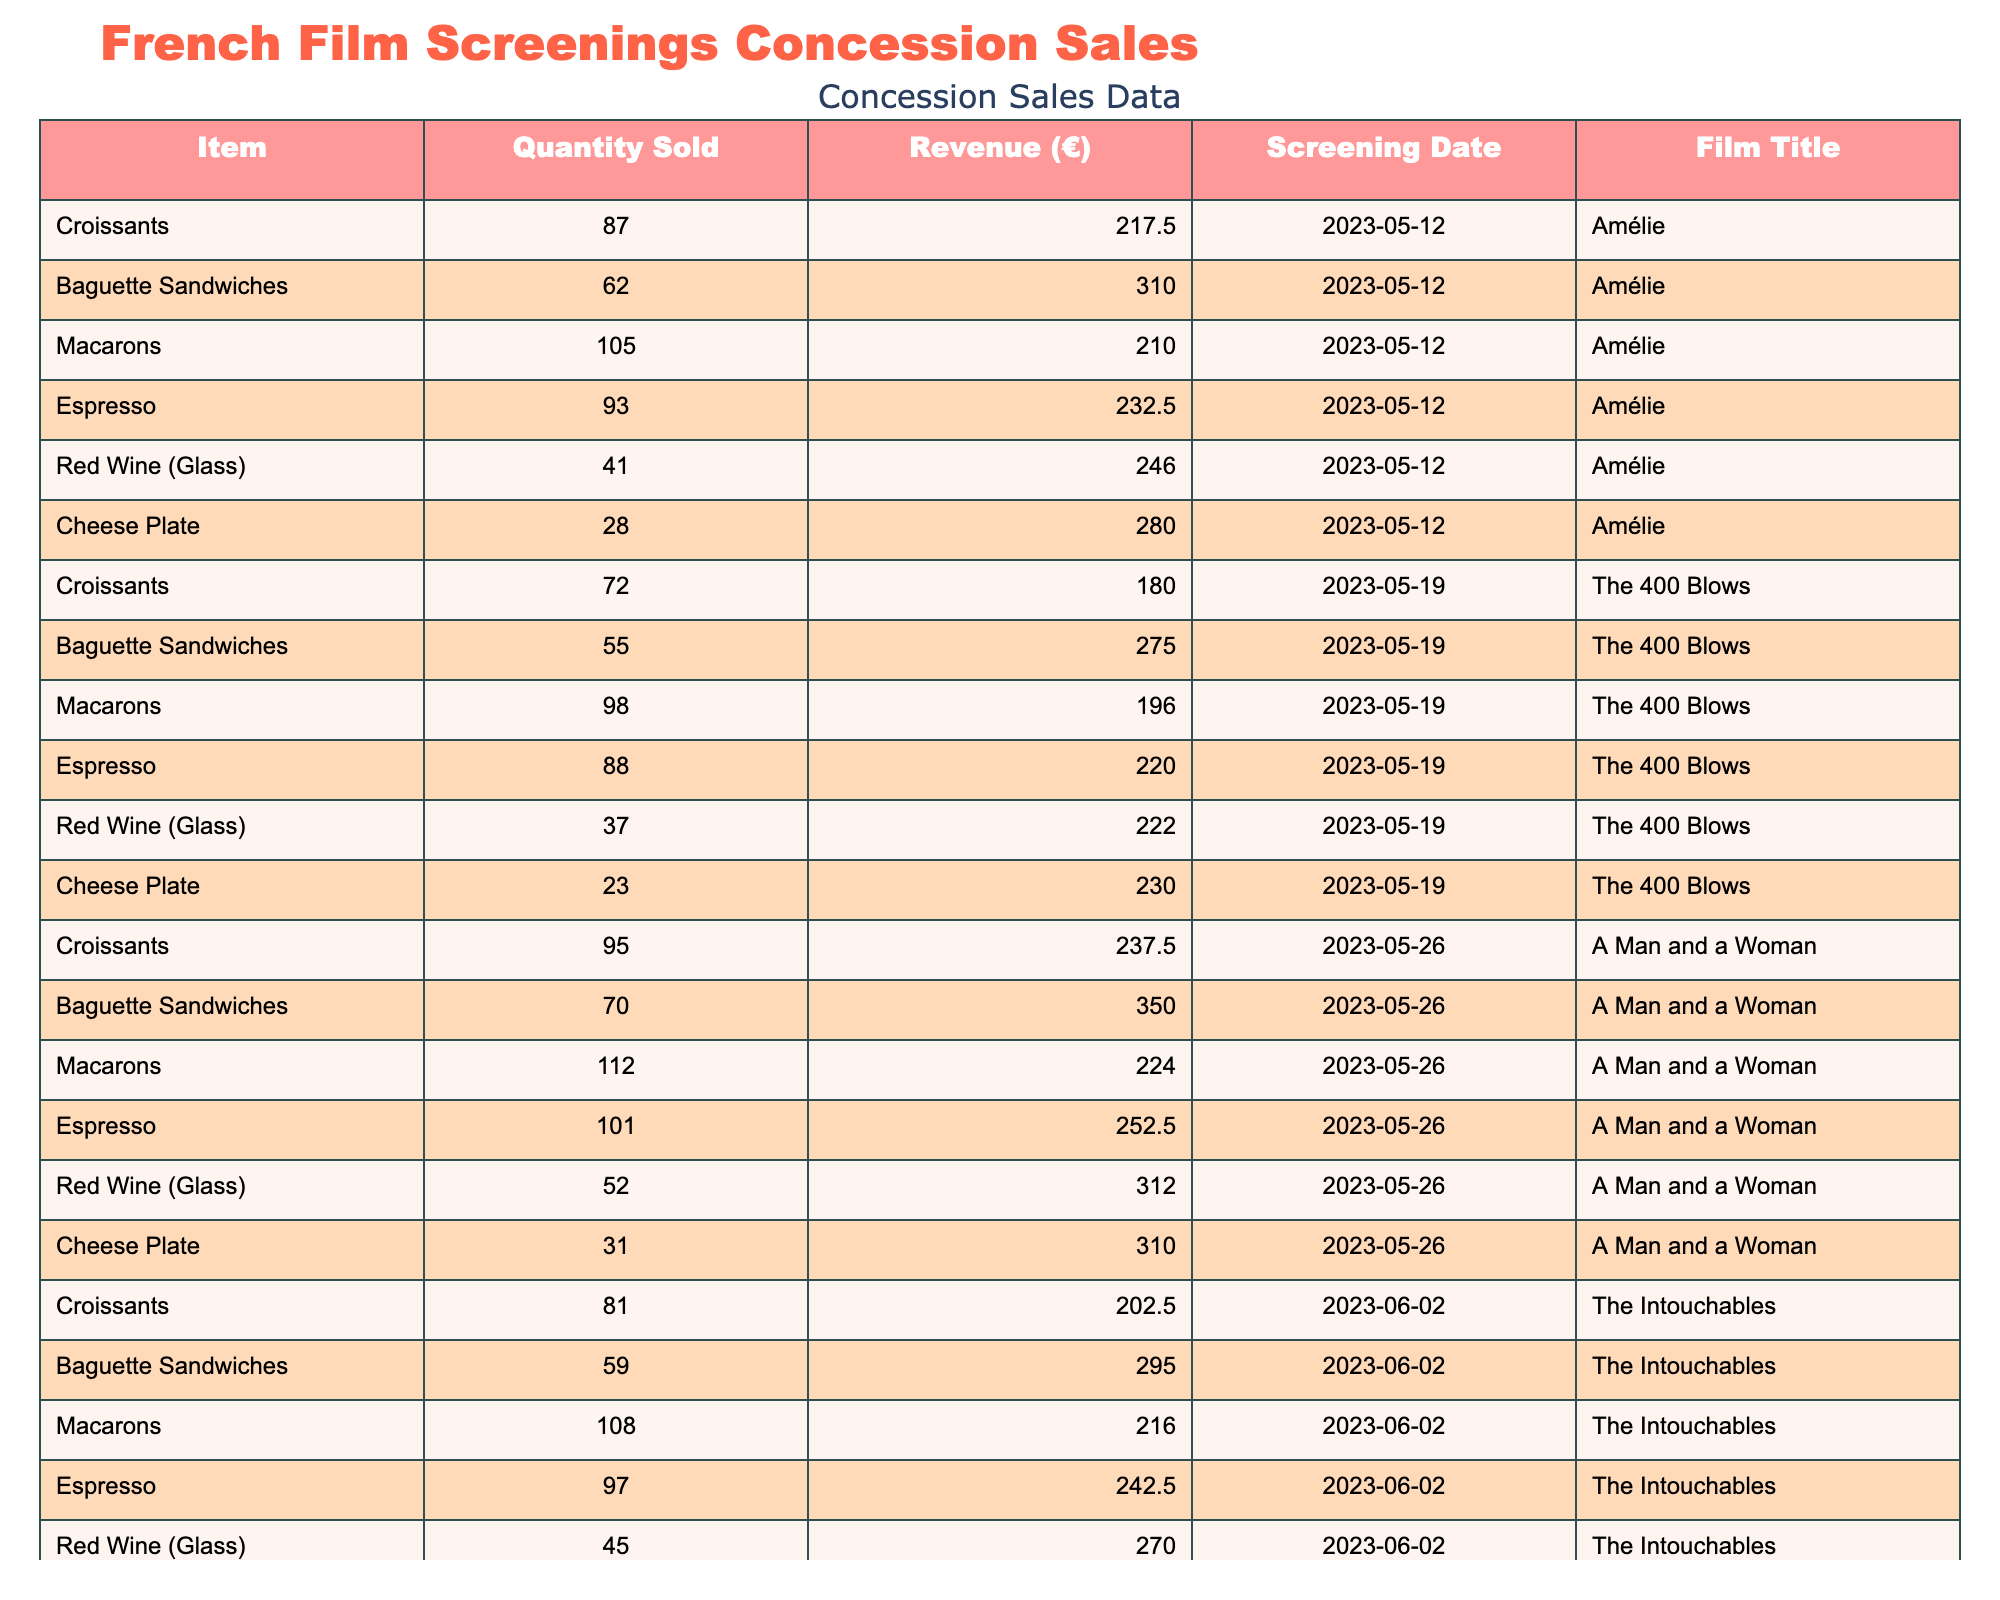What film generated the highest total revenue from concession sales? To find the film with the highest total revenue, I need to sum the revenue for each film based on the screening date. I calculate the total revenue for each film: Amélie = 1,486.00 €, The 400 Blows = 1,180.00 €, A Man and a Woman = 1,425.00 €, The Intouchables = 1,258.50 €. Amélie has the highest total revenue.
Answer: Amélie What was the quantity of macaron sales for "A Man and a Woman"? I look at the row for "A Man and a Woman" and see that the quantity sold for macarons is listed as 112.
Answer: 112 Which item had the lowest revenue during the screening of "The Intouchables"? I need to compare the revenues for each item sold during "The Intouchables": Croissants = 202.50 €, Baguette Sandwiches = 295.00 €, Macarons = 216.00 €, Espresso = 242.50 €, Red Wine (Glass) = 270.00 €, Cheese Plate = 260.00 €. The lowest revenue is for Croissants.
Answer: Croissants What is the average quantity sold of Baguette Sandwiches across all screenings? I sum the quantities of Baguette Sandwiches sold: 62 + 55 + 70 + 59 = 246. Then, I divide by the number of screenings, which is 4. So, 246 / 4 = 61.5.
Answer: 61.5 Did the sales of Cheese Plates increase, decrease, or remain the same from "The 400 Blows" to "A Man and a Woman"? For "The 400 Blows," the quantity sold was 23 and for "A Man and a Woman," it was 31. Since 31 is greater than 23, the sales of Cheese Plates increased.
Answer: Increased What item had the highest quantity sold on the screening date of "The 400 Blows"? I look at the row for "The 400 Blows" and see the quantities for each item: Croissants = 72, Baguette Sandwiches = 55, Macarons = 98, Espresso = 88, Red Wine (Glass) = 37, Cheese Plate = 23. Macarons have the highest quantity sold.
Answer: Macarons What was the total revenue generated from Espresso sales across all screenings? I sum the revenues for Espresso: 232.50 + 220.00 + 252.50 + 242.50 = 947.50.
Answer: 947.50 Which screening had the lowest revenue from Cheese Plate sales? I compare the Cheese Plate revenues for each film: Amélie = 280.00 €, The 400 Blows = 230.00 €, A Man and a Woman = 310.00 €, The Intouchables = 260.00 €. The lowest revenue from Cheese Plate sales was for "The 400 Blows."
Answer: The 400 Blows How much more revenue was generated from Red Wine sales for "A Man and a Woman" compared to "The Intouchables"? For "A Man and a Woman," Red Wine revenue is 312.00 €, and for "The Intouchables," it’s 270.00 €. The difference is 312.00 - 270.00 = 42.00 €.
Answer: 42.00 What is the total revenue generated from all items sold during the screening of "Amélie"? I sum all revenues from "Amélie": Croissants = 217.50 €, Baguette Sandwiches = 310.00 €, Macarons = 210.00 €, Espresso = 232.50 €, Red Wine (Glass) = 246.00 €, Cheese Plate = 280.00 €. The total revenue is 217.50 + 310.00 + 210.00 + 232.50 + 246.00 + 280.00 = 1,486.00 €.
Answer: 1,486.00 